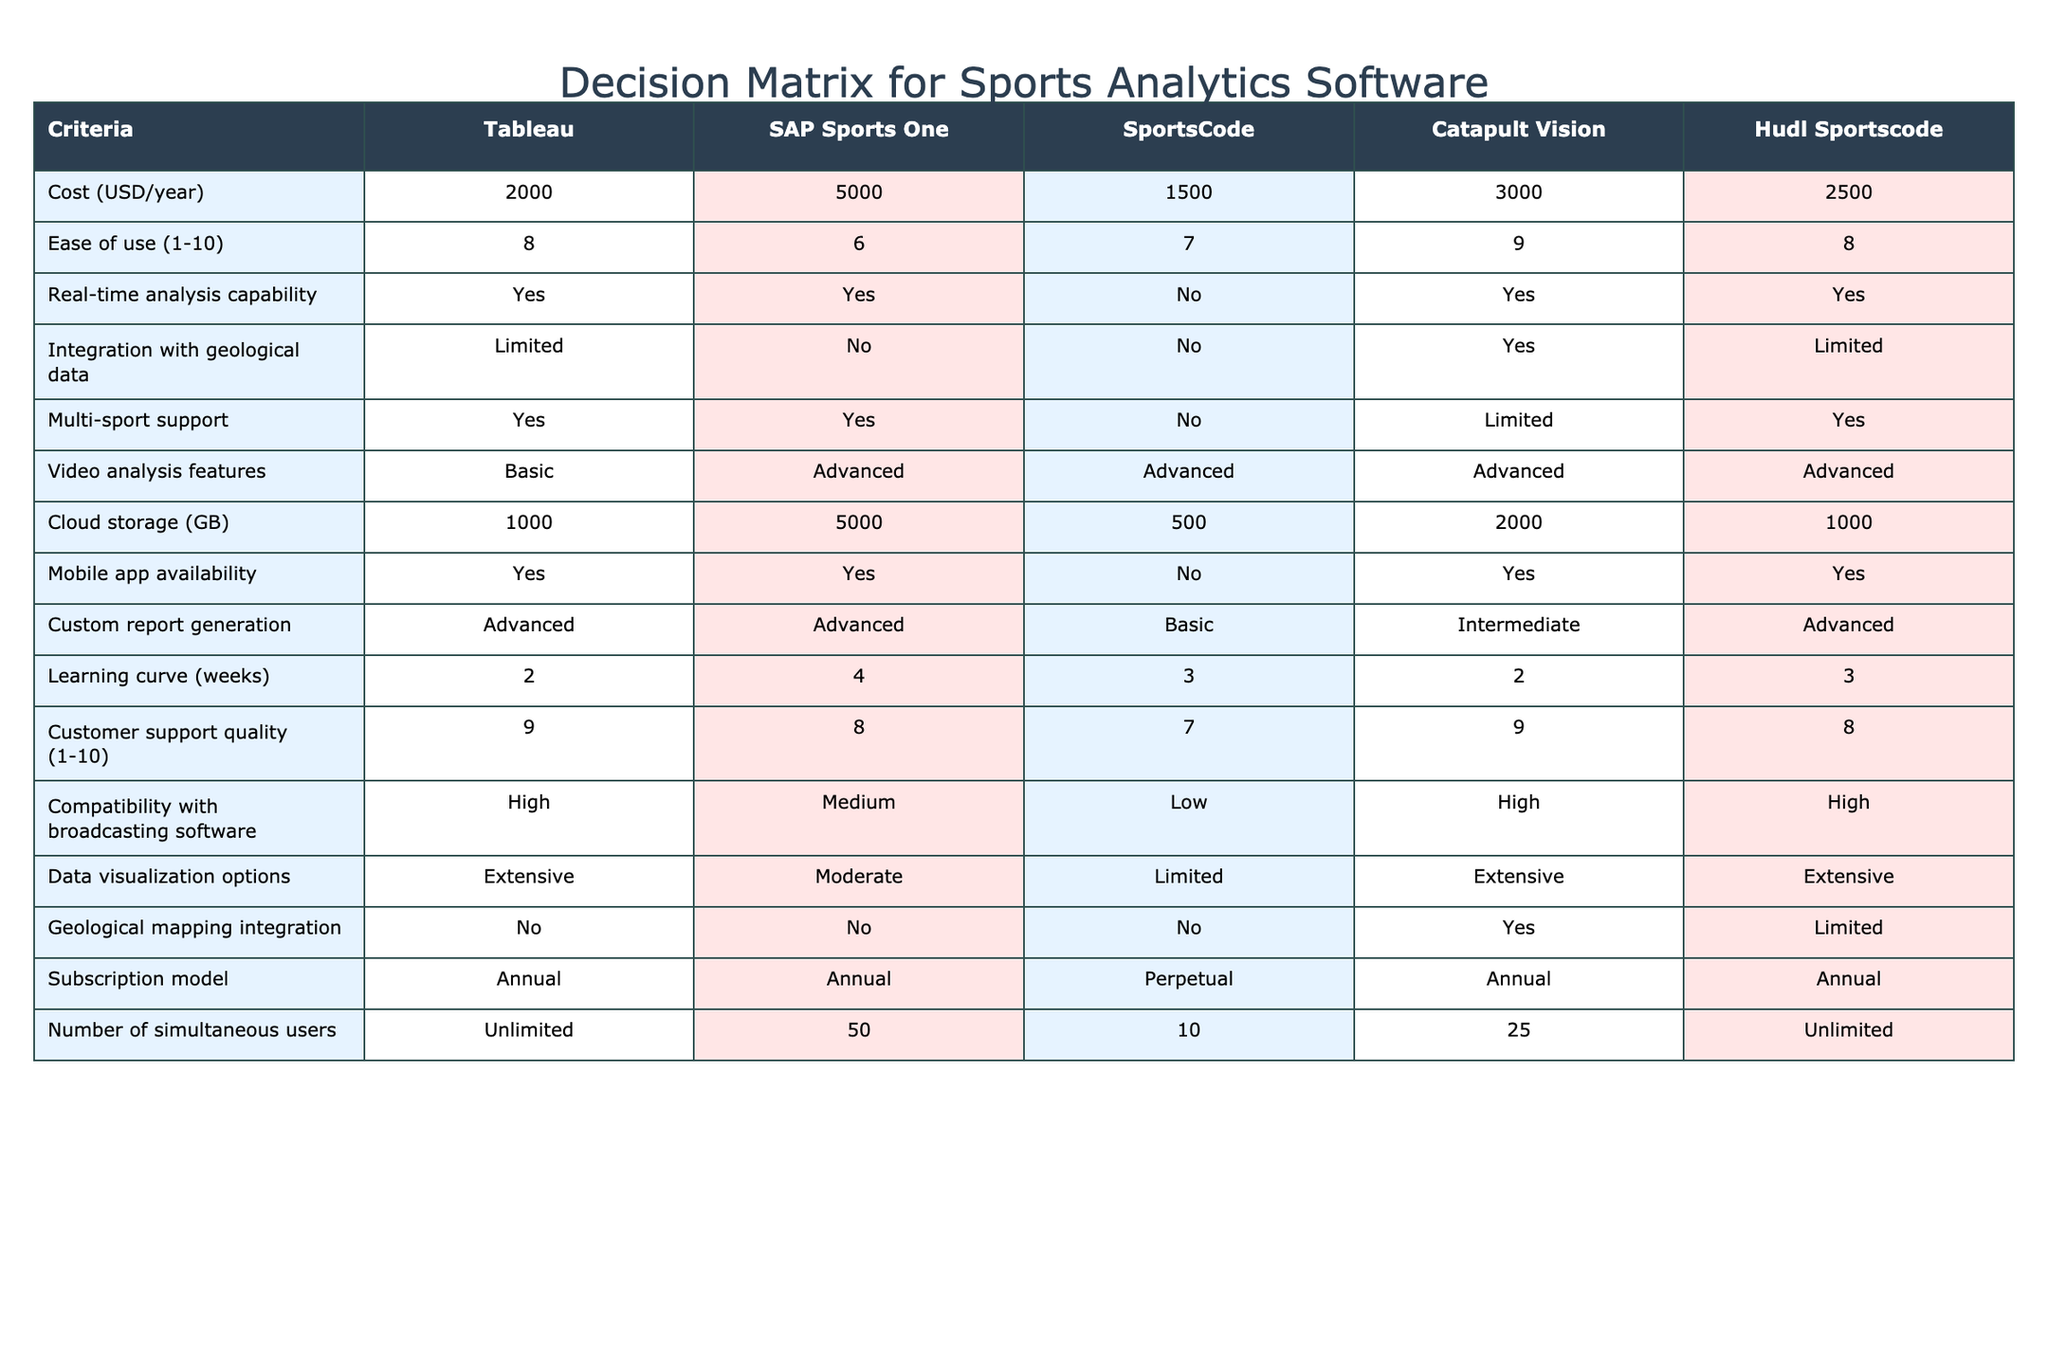What is the cost of SAP Sports One per year? The table lists the cost for each software option in the "Cost (USD/year)" row. For SAP Sports One, the cost is specifically stated as 5000 USD.
Answer: 5000 Which sports analytics software has the highest customer support quality rating? The "Customer support quality (1-10)" column displays ratings for each software. By comparing the values, both Tableau and Catapult Vision have the highest score of 9.
Answer: Tableau and Catapult Vision Is there any software that supports limited multi-sport capabilities? The "Multi-sport support" column reveals the capabilities of each software. Catapult Vision and SportsCode are marked as having limited support.
Answer: Yes, Catapult Vision and SportsCode What is the average cost of the software options listed in the table? To calculate the average cost, sum the costs of all software (2000 + 5000 + 1500 + 3000 + 2500 = 14500). There are 5 options, so dividing gives us an average of 14500/5 = 2900.
Answer: 2900 Does any software offer advanced video analysis features? The "Video analysis features" column indicates the level of video analysis each software provides. All options except SportsCode have advanced features, indicating a positive outcome for the question.
Answer: Yes, all except SportsCode Which software has the best ease of use rating? The "Ease of use (1-10)" column lists the ratings. Tableau and Hudl Sportscode both have a score of 8, but Tableau appears first based on its order.
Answer: Tableau How many simultaneous users can SportsCode accommodate? The "Number of simultaneous users" column shows that SportsCode can accommodate 10 users. This is a direct retrieval from the respective row.
Answer: 10 Does Catapult Vision integrate with any geological data? The "Integration with geological data" column shows that Catapult Vision has a Yes under its name, indicating that it does integrate with geological data.
Answer: Yes Which software allows the most number of simultaneous users, and how many? By checking the "Number of simultaneous users" column, both Tableau and Hudl Sportscode have unlimited use, which is the highest capability among the software.
Answer: Tableau and Hudl Sportscode, Unlimited 